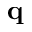<formula> <loc_0><loc_0><loc_500><loc_500>q</formula> 